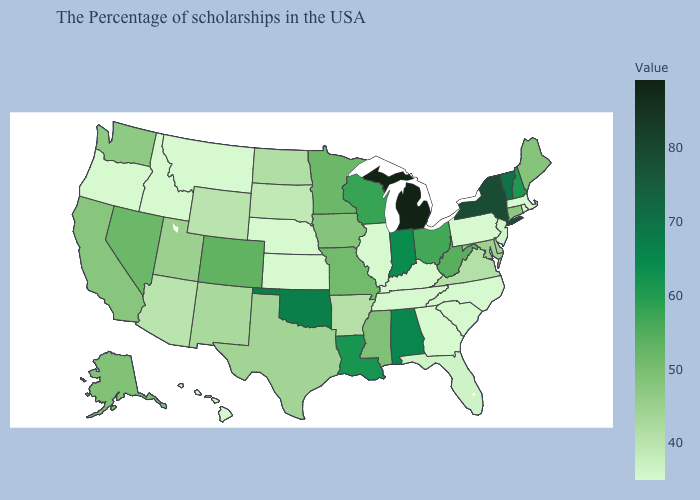Among the states that border Washington , which have the lowest value?
Give a very brief answer. Idaho, Oregon. Does Arkansas have a higher value than Oregon?
Give a very brief answer. Yes. 